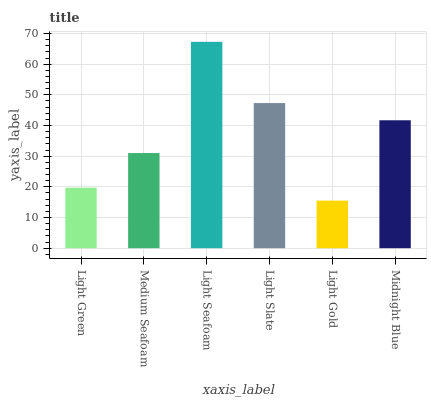Is Light Gold the minimum?
Answer yes or no. Yes. Is Light Seafoam the maximum?
Answer yes or no. Yes. Is Medium Seafoam the minimum?
Answer yes or no. No. Is Medium Seafoam the maximum?
Answer yes or no. No. Is Medium Seafoam greater than Light Green?
Answer yes or no. Yes. Is Light Green less than Medium Seafoam?
Answer yes or no. Yes. Is Light Green greater than Medium Seafoam?
Answer yes or no. No. Is Medium Seafoam less than Light Green?
Answer yes or no. No. Is Midnight Blue the high median?
Answer yes or no. Yes. Is Medium Seafoam the low median?
Answer yes or no. Yes. Is Light Gold the high median?
Answer yes or no. No. Is Light Slate the low median?
Answer yes or no. No. 